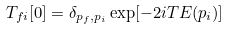Convert formula to latex. <formula><loc_0><loc_0><loc_500><loc_500>T _ { f i } [ 0 ] = \delta _ { p _ { f } , p _ { i } } \exp [ - 2 i T E ( p _ { i } ) ]</formula> 